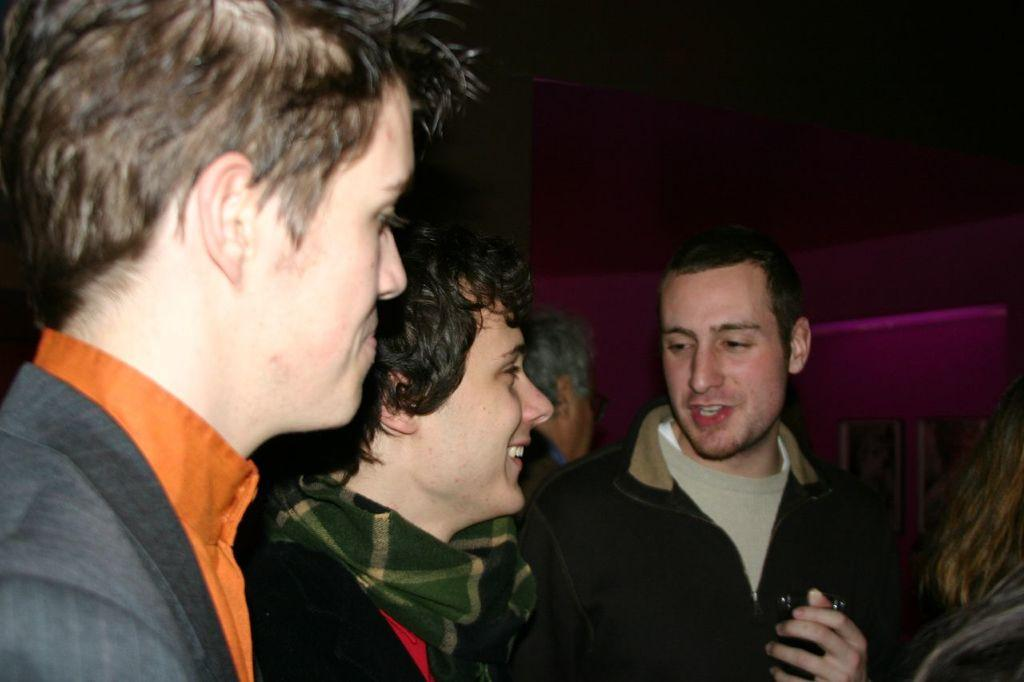How many people are in the image? There is a group of people standing in the image. What is one person holding in his hand? One person is holding a glass in his hand. What can be seen on the right side of the image? There are photo frames on the wall on the right side of the image. Is there any rain visible in the image? There is no rain visible in the image. What type of hair can be seen on the people in the image? The provided facts do not mention hair, so we cannot determine the type of hair visible in the image. 